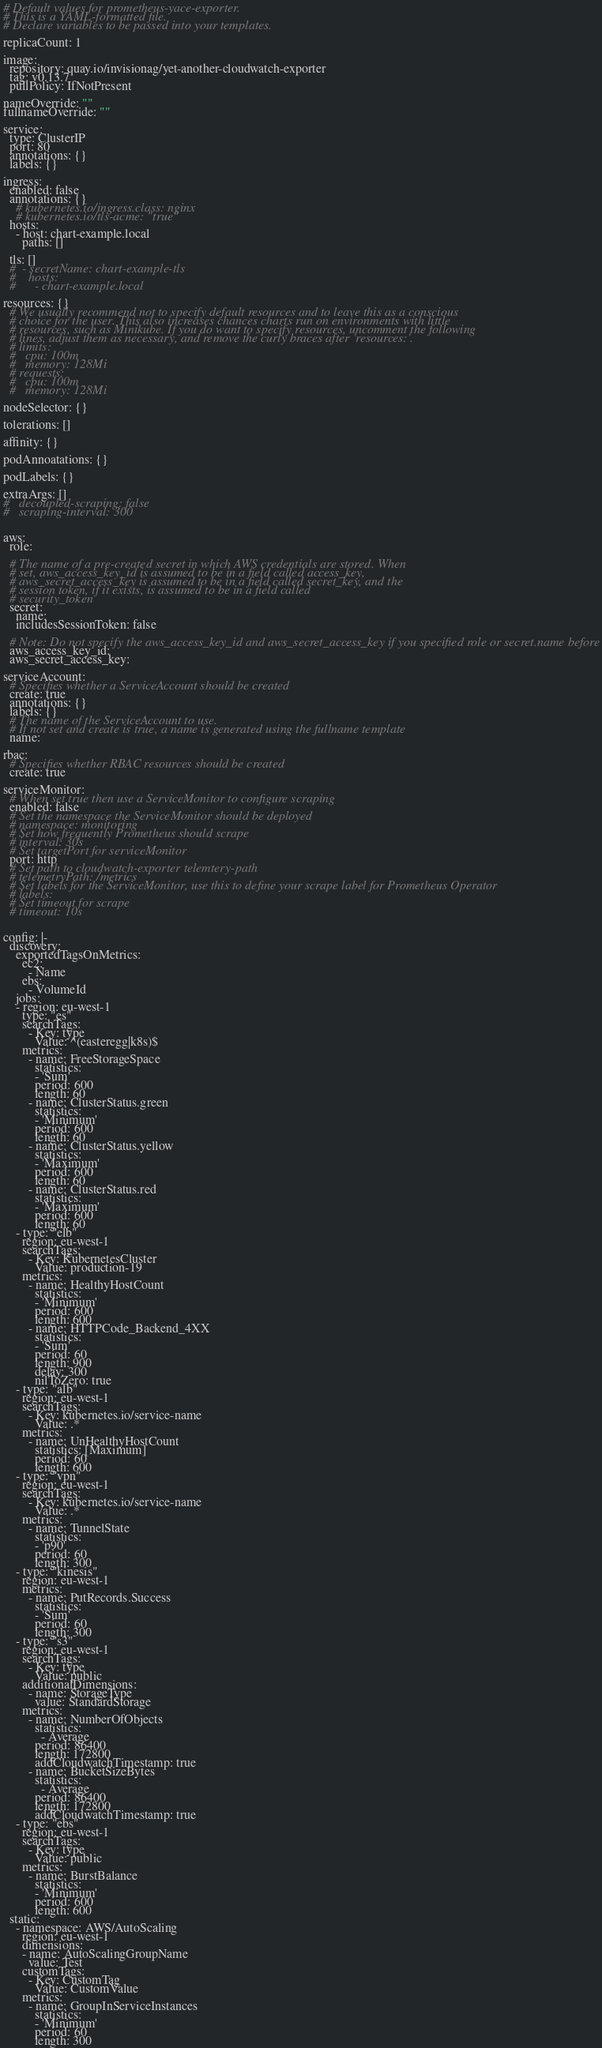Convert code to text. <code><loc_0><loc_0><loc_500><loc_500><_YAML_># Default values for prometheus-yace-exporter.
# This is a YAML-formatted file.
# Declare variables to be passed into your templates.

replicaCount: 1

image:
  repository: quay.io/invisionag/yet-another-cloudwatch-exporter
  tag: v0.13.7
  pullPolicy: IfNotPresent

nameOverride: ""
fullnameOverride: ""

service:
  type: ClusterIP
  port: 80
  annotations: {}
  labels: {}

ingress:
  enabled: false
  annotations: {}
    # kubernetes.io/ingress.class: nginx
    # kubernetes.io/tls-acme: "true"
  hosts:
    - host: chart-example.local
      paths: []

  tls: []
  #  - secretName: chart-example-tls
  #    hosts:
  #      - chart-example.local

resources: {}
  # We usually recommend not to specify default resources and to leave this as a conscious
  # choice for the user. This also increases chances charts run on environments with little
  # resources, such as Minikube. If you do want to specify resources, uncomment the following
  # lines, adjust them as necessary, and remove the curly braces after 'resources:'.
  # limits:
  #   cpu: 100m
  #   memory: 128Mi
  # requests:
  #   cpu: 100m
  #   memory: 128Mi

nodeSelector: {}

tolerations: []

affinity: {}

podAnnoatations: {}

podLabels: {}

extraArgs: []
#   decoupled-scraping: false
#   scraping-interval: 300


aws:
  role:

  # The name of a pre-created secret in which AWS credentials are stored. When
  # set, aws_access_key_id is assumed to be in a field called access_key,
  # aws_secret_access_key is assumed to be in a field called secret_key, and the
  # session token, if it exists, is assumed to be in a field called
  # security_token
  secret:
    name:
    includesSessionToken: false

  # Note: Do not specify the aws_access_key_id and aws_secret_access_key if you specified role or secret.name before
  aws_access_key_id:
  aws_secret_access_key:

serviceAccount:
  # Specifies whether a ServiceAccount should be created
  create: true
  annotations: {}
  labels: {}
  # The name of the ServiceAccount to use.
  # If not set and create is true, a name is generated using the fullname template
  name:

rbac:
  # Specifies whether RBAC resources should be created
  create: true

serviceMonitor:
  # When set true then use a ServiceMonitor to configure scraping
  enabled: false
  # Set the namespace the ServiceMonitor should be deployed
  # namespace: monitoring
  # Set how frequently Prometheus should scrape
  # interval: 30s
  # Set targetPort for serviceMonitor
  port: http
  # Set path to cloudwatch-exporter telemtery-path
  # telemetryPath: /metrics
  # Set labels for the ServiceMonitor, use this to define your scrape label for Prometheus Operator
  # labels:
  # Set timeout for scrape
  # timeout: 10s


config: |-
  discovery:
    exportedTagsOnMetrics:
      ec2:
        - Name
      ebs:
        - VolumeId
    jobs:
    - region: eu-west-1
      type: "es"
      searchTags:
        - Key: type
          Value: ^(easteregg|k8s)$
      metrics:
        - name: FreeStorageSpace
          statistics:
          - 'Sum'
          period: 600
          length: 60
        - name: ClusterStatus.green
          statistics:
          - 'Minimum'
          period: 600
          length: 60
        - name: ClusterStatus.yellow
          statistics:
          - 'Maximum'
          period: 600
          length: 60
        - name: ClusterStatus.red
          statistics:
          - 'Maximum'
          period: 600
          length: 60
    - type: "elb"
      region: eu-west-1
      searchTags:
        - Key: KubernetesCluster
          Value: production-19
      metrics:
        - name: HealthyHostCount
          statistics:
          - 'Minimum'
          period: 600
          length: 600
        - name: HTTPCode_Backend_4XX
          statistics:
          - 'Sum'
          period: 60
          length: 900
          delay: 300
          nilToZero: true
    - type: "alb"
      region: eu-west-1
      searchTags:
        - Key: kubernetes.io/service-name
          Value: .*
      metrics:
        - name: UnHealthyHostCount
          statistics: [Maximum]
          period: 60
          length: 600
    - type: "vpn"
      region: eu-west-1
      searchTags:
        - Key: kubernetes.io/service-name
          Value: .*
      metrics:
        - name: TunnelState
          statistics:
          - 'p90'
          period: 60
          length: 300
    - type: "kinesis"
      region: eu-west-1
      metrics:
        - name: PutRecords.Success
          statistics:
          - 'Sum'
          period: 60
          length: 300
    - type: "s3"
      region: eu-west-1
      searchTags:
        - Key: type
          Value: public
      additionalDimensions:
        - name: StorageType
          value: StandardStorage
      metrics:
        - name: NumberOfObjects
          statistics:
            - Average
          period: 86400
          length: 172800
          addCloudwatchTimestamp: true
        - name: BucketSizeBytes
          statistics:
            - Average
          period: 86400
          length: 172800
          addCloudwatchTimestamp: true
    - type: "ebs"
      region: eu-west-1
      searchTags:
        - Key: type
          Value: public
      metrics:
        - name: BurstBalance
          statistics:
          - 'Minimum'
          period: 600
          length: 600
  static:
    - namespace: AWS/AutoScaling
      region: eu-west-1
      dimensions:
      - name: AutoScalingGroupName
        value: Test
      customTags:
        - Key: CustomTag
          Value: CustomValue
      metrics:
        - name: GroupInServiceInstances
          statistics:
          - 'Minimum'
          period: 60
          length: 300
</code> 